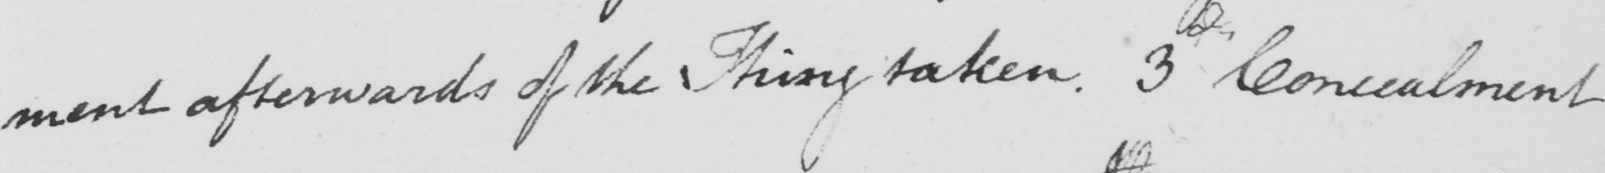Transcribe the text shown in this historical manuscript line. -ment afterwards of the Thing taken . 3d Concealment 